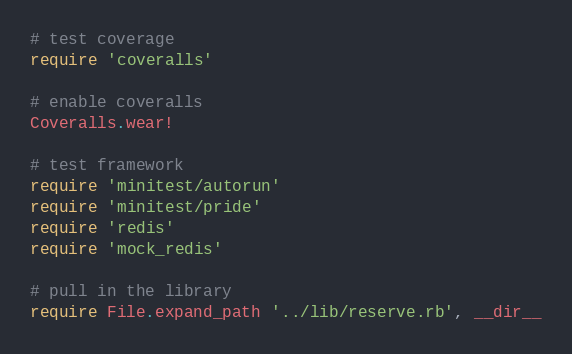<code> <loc_0><loc_0><loc_500><loc_500><_Ruby_># test coverage
require 'coveralls'

# enable coveralls
Coveralls.wear!

# test framework
require 'minitest/autorun'
require 'minitest/pride'
require 'redis'
require 'mock_redis'

# pull in the library
require File.expand_path '../lib/reserve.rb', __dir__
</code> 